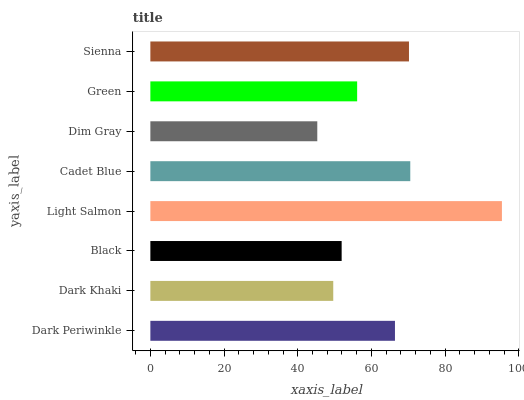Is Dim Gray the minimum?
Answer yes or no. Yes. Is Light Salmon the maximum?
Answer yes or no. Yes. Is Dark Khaki the minimum?
Answer yes or no. No. Is Dark Khaki the maximum?
Answer yes or no. No. Is Dark Periwinkle greater than Dark Khaki?
Answer yes or no. Yes. Is Dark Khaki less than Dark Periwinkle?
Answer yes or no. Yes. Is Dark Khaki greater than Dark Periwinkle?
Answer yes or no. No. Is Dark Periwinkle less than Dark Khaki?
Answer yes or no. No. Is Dark Periwinkle the high median?
Answer yes or no. Yes. Is Green the low median?
Answer yes or no. Yes. Is Dim Gray the high median?
Answer yes or no. No. Is Dark Periwinkle the low median?
Answer yes or no. No. 